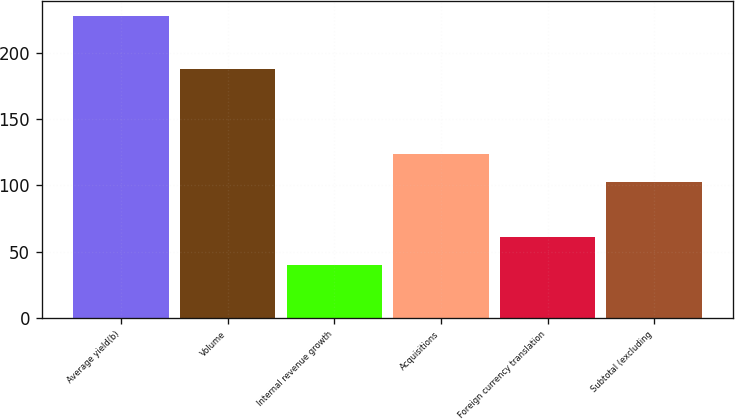<chart> <loc_0><loc_0><loc_500><loc_500><bar_chart><fcel>Average yield(b)<fcel>Volume<fcel>Internal revenue growth<fcel>Acquisitions<fcel>Foreign currency translation<fcel>Subtotal (excluding<nl><fcel>228<fcel>188<fcel>40<fcel>124<fcel>61<fcel>103<nl></chart> 